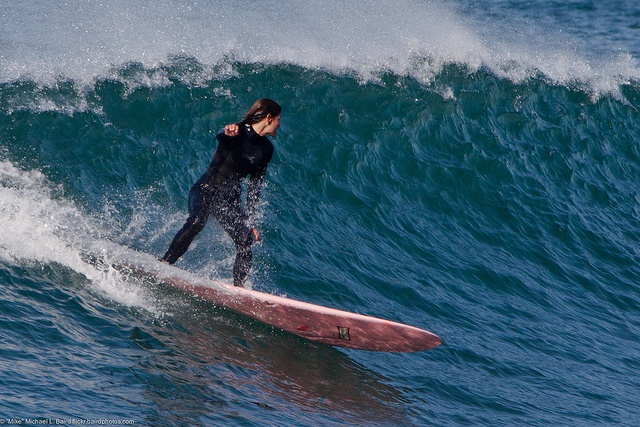Describe the objects in this image and their specific colors. I can see people in gray, black, blue, and darkblue tones and surfboard in gray, darkgray, brown, and maroon tones in this image. 